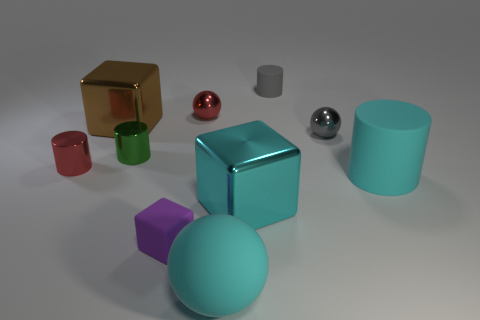Subtract 1 cylinders. How many cylinders are left? 3 Subtract all cubes. How many objects are left? 7 Add 8 brown metallic things. How many brown metallic things are left? 9 Add 8 small green cylinders. How many small green cylinders exist? 9 Subtract 0 green cubes. How many objects are left? 10 Subtract all big cyan blocks. Subtract all large cyan rubber things. How many objects are left? 7 